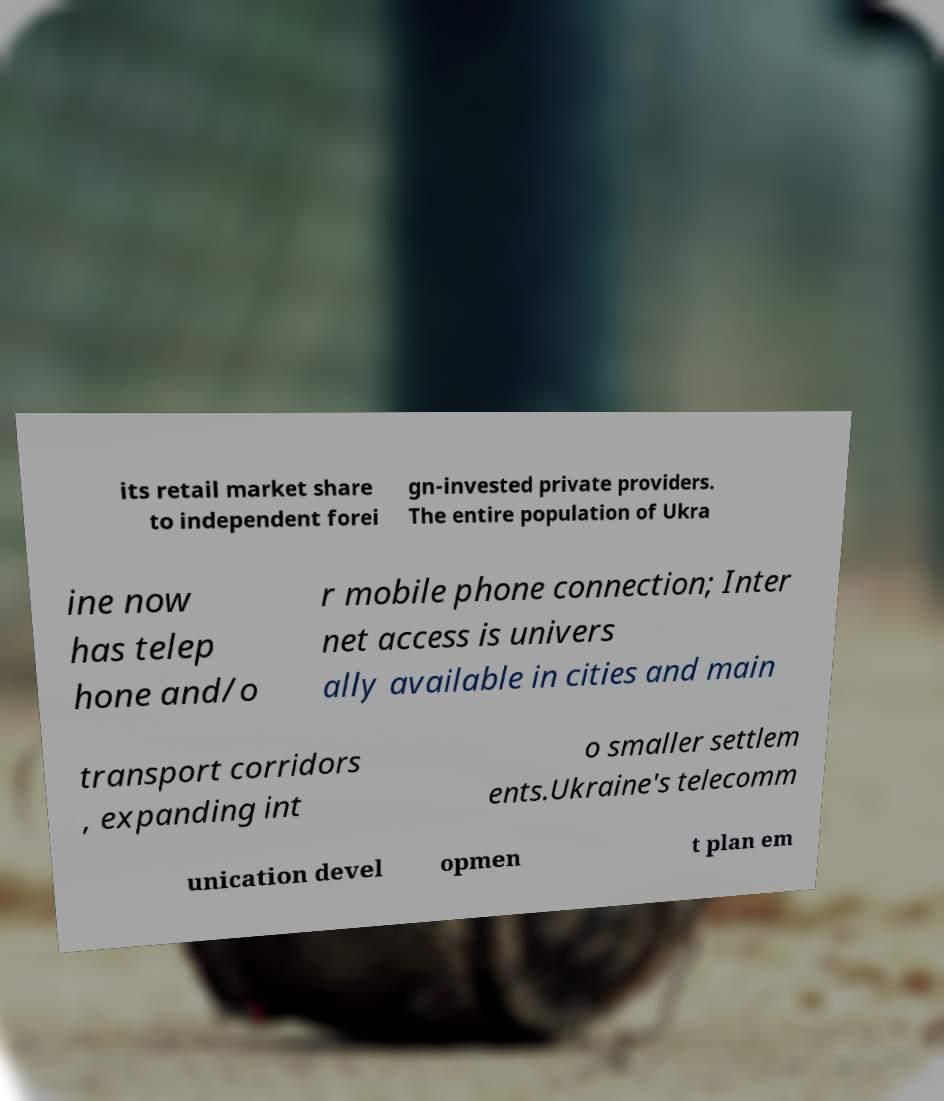There's text embedded in this image that I need extracted. Can you transcribe it verbatim? its retail market share to independent forei gn-invested private providers. The entire population of Ukra ine now has telep hone and/o r mobile phone connection; Inter net access is univers ally available in cities and main transport corridors , expanding int o smaller settlem ents.Ukraine's telecomm unication devel opmen t plan em 